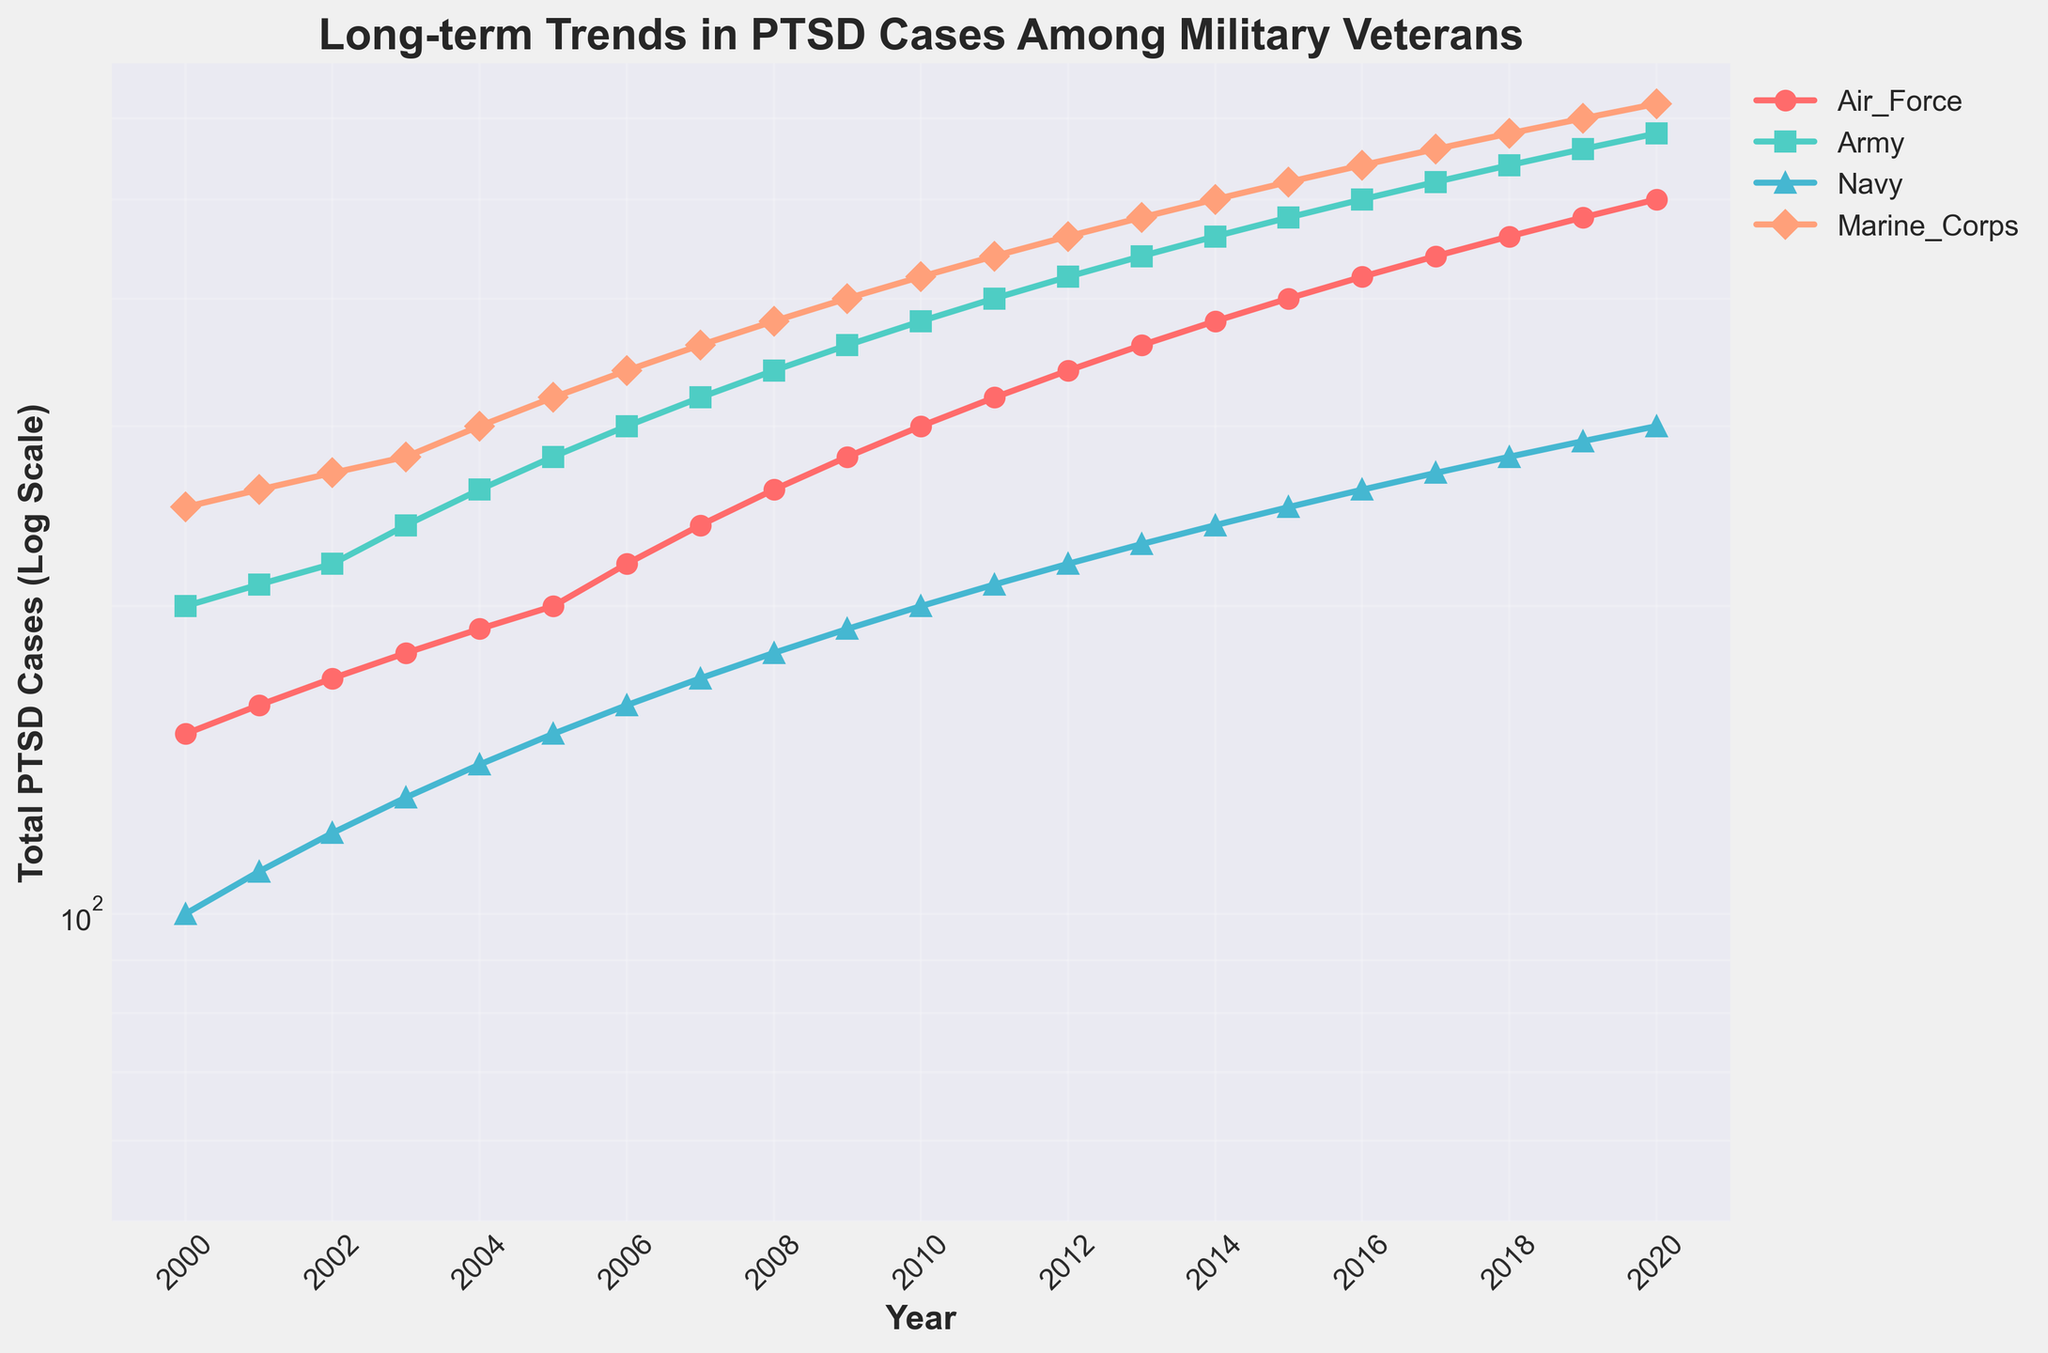Which branch of the military has the highest number of PTSD cases in 2010? By looking at the y-axis values for the year 2010, we can compare the heights of the line markers representing different branches. The Marine Corps line is the highest, indicating they have the most PTSD cases in 2010.
Answer: Marine Corps How do PTSD cases in the Air Force compare to the Navy in 2005? Locate the year 2005 on the x-axis and compare the y-axis positions of the Air Force and Navy lines. The Air Force line is higher than the Navy line, indicating more PTSD cases in the Air Force.
Answer: Air Force has more cases What is the trend in PTSD cases for the Army from 2000 to 2020? By following the Army's line from 2000 to 2020, we observe a consistent upward trend, suggesting a steady increase in PTSD cases over the years.
Answer: Increasing Between which two consecutive years did the Marine Corps experience the largest increase in PTSD cases? Calculate the difference in the number of PTSD cases for each pair of consecutive years by following the Marine Corps line. The largest gap appears between 2019 and 2020.
Answer: 2019 to 2020 Estimate the relative change in Navy PTSD cases from 2005 to 2010 on the log scale. Identify the points for 2005 and 2010 on the Navy's line. The value moves from approximately 150 to 200, representing a proportionate increase. On a log scale, this increase in values means a relative change not an absolute one, indicating doubling or a significant rate of growth.
Answer: Significant growth What does the log scale of the y-axis indicate about the nature of the data? The semilogarithmic scale compresses large numerical changes and reveals multiplicative relationships, showing exponential growth more clearly.
Answer: Exponential growth Which branch had the fewest PTSD cases in 2015 and how do you know? Locate the year 2015 on the x-axis and compare the y-axis positions of all branches. The Navy line is the lowest, indicating the fewest PTSD cases.
Answer: Navy How did PTSD cases for the Army change between 2008 and 2012? Look at the Army line between the years 2008 and 2012. The line goes from around 340 to 420, indicating an increase in PTSD cases.
Answer: Increased By how much did PTSD cases in the Marine Corps increase from 2003 to 2020? Find the PTSD cases for the Marine Corps in 2003 (280) and in 2020 (620). Subtract the 2003 value from the 2020 value to find the increase: 620 - 280 = 340.
Answer: 340 Comparing 2014 and 2018, which branch showed the smallest increase in PTSD cases? Identify the values for 2014 and 2018 for all branches and calculate the differences. The Navy has the smallest difference (240 to 280), indicating the smallest increase.
Answer: Navy 